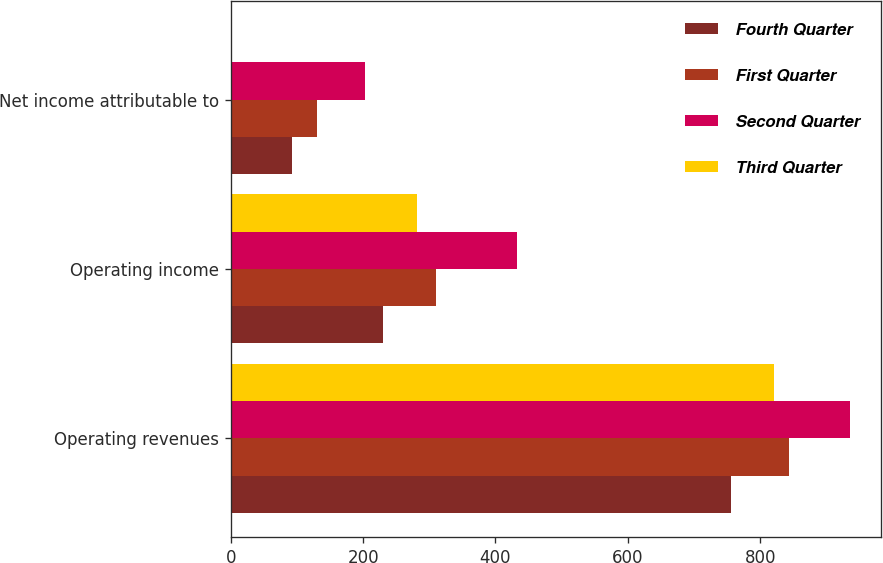Convert chart to OTSL. <chart><loc_0><loc_0><loc_500><loc_500><stacked_bar_chart><ecel><fcel>Operating revenues<fcel>Operating income<fcel>Net income attributable to<nl><fcel>Fourth Quarter<fcel>756<fcel>230<fcel>93<nl><fcel>First Quarter<fcel>844<fcel>310<fcel>131<nl><fcel>Second Quarter<fcel>936<fcel>432<fcel>203<nl><fcel>Third Quarter<fcel>821<fcel>281<fcel>1<nl></chart> 